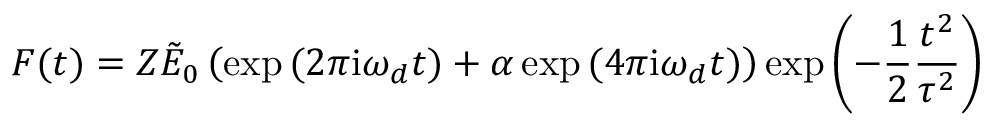<formula> <loc_0><loc_0><loc_500><loc_500>F ( t ) = Z \tilde { E } _ { 0 } \left ( \exp { ( 2 \pi i \omega _ { d } t ) } + \alpha \exp { ( 4 \pi i \omega _ { d } t ) } \right ) \exp { \left ( - \frac { 1 } { 2 } \frac { t ^ { 2 } } { \tau ^ { 2 } } \right ) }</formula> 